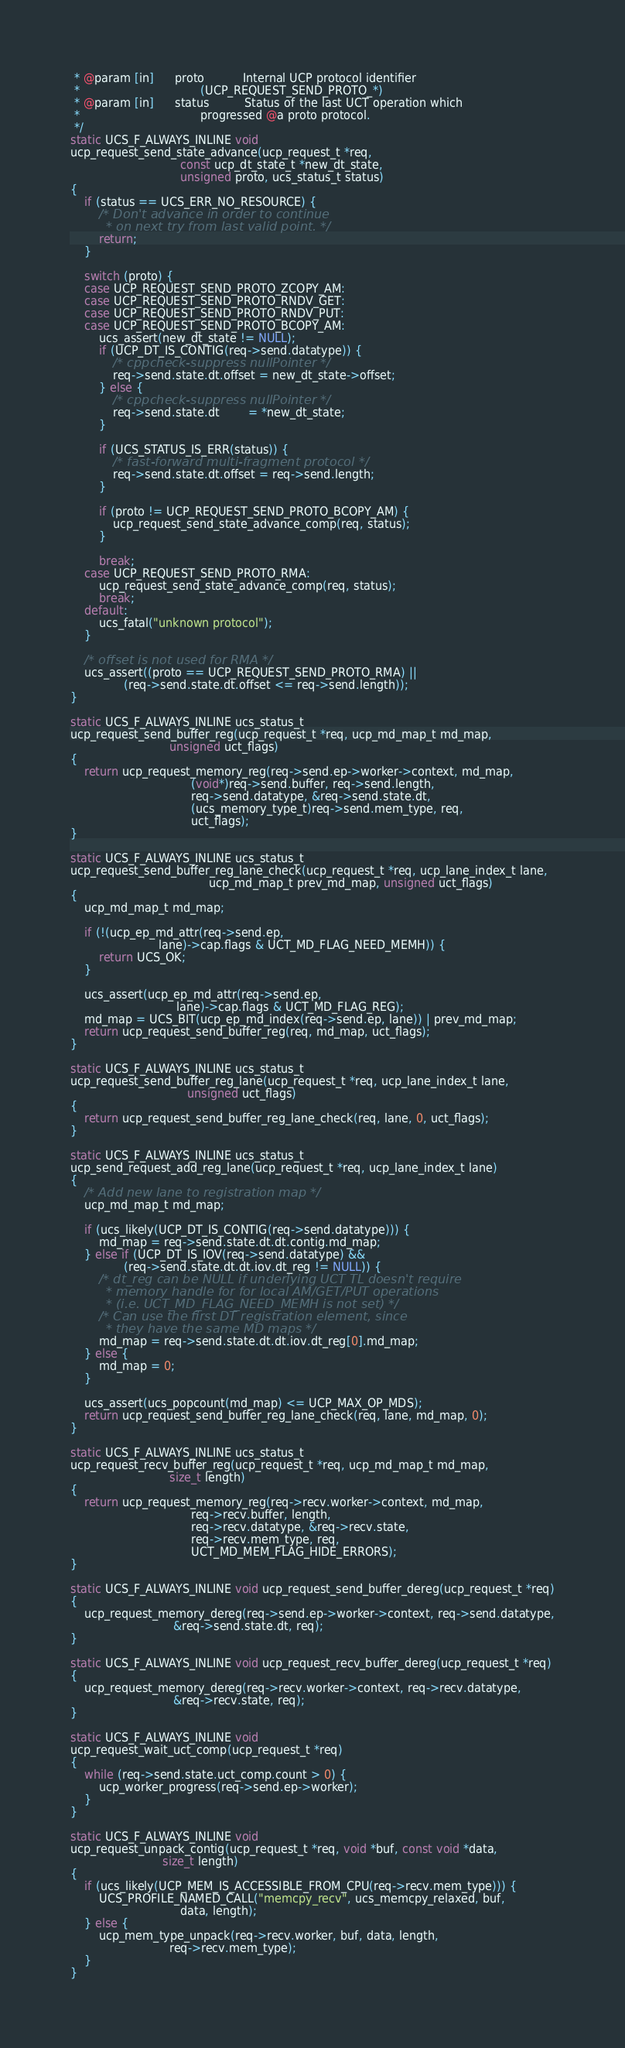<code> <loc_0><loc_0><loc_500><loc_500><_C++_> * @param [in]      proto           Internal UCP protocol identifier
 *                                  (UCP_REQUEST_SEND_PROTO_*)
 * @param [in]      status          Status of the last UCT operation which
 *                                  progressed @a proto protocol.
 */
static UCS_F_ALWAYS_INLINE void
ucp_request_send_state_advance(ucp_request_t *req,
                               const ucp_dt_state_t *new_dt_state,
                               unsigned proto, ucs_status_t status)
{
    if (status == UCS_ERR_NO_RESOURCE) {
        /* Don't advance in order to continue
         * on next try from last valid point. */
        return;
    }

    switch (proto) {
    case UCP_REQUEST_SEND_PROTO_ZCOPY_AM:
    case UCP_REQUEST_SEND_PROTO_RNDV_GET:
    case UCP_REQUEST_SEND_PROTO_RNDV_PUT:
    case UCP_REQUEST_SEND_PROTO_BCOPY_AM:
        ucs_assert(new_dt_state != NULL);
        if (UCP_DT_IS_CONTIG(req->send.datatype)) {
            /* cppcheck-suppress nullPointer */
            req->send.state.dt.offset = new_dt_state->offset;
        } else {
            /* cppcheck-suppress nullPointer */
            req->send.state.dt        = *new_dt_state;
        }

        if (UCS_STATUS_IS_ERR(status)) {
            /* fast-forward multi-fragment protocol */
            req->send.state.dt.offset = req->send.length;
        }

        if (proto != UCP_REQUEST_SEND_PROTO_BCOPY_AM) {
            ucp_request_send_state_advance_comp(req, status);
        }

        break;
    case UCP_REQUEST_SEND_PROTO_RMA:
        ucp_request_send_state_advance_comp(req, status);
        break;
    default:
        ucs_fatal("unknown protocol");
    }

    /* offset is not used for RMA */
    ucs_assert((proto == UCP_REQUEST_SEND_PROTO_RMA) ||
               (req->send.state.dt.offset <= req->send.length));
}

static UCS_F_ALWAYS_INLINE ucs_status_t
ucp_request_send_buffer_reg(ucp_request_t *req, ucp_md_map_t md_map,
                            unsigned uct_flags)
{
    return ucp_request_memory_reg(req->send.ep->worker->context, md_map,
                                  (void*)req->send.buffer, req->send.length,
                                  req->send.datatype, &req->send.state.dt,
                                  (ucs_memory_type_t)req->send.mem_type, req,
                                  uct_flags);
}

static UCS_F_ALWAYS_INLINE ucs_status_t
ucp_request_send_buffer_reg_lane_check(ucp_request_t *req, ucp_lane_index_t lane,
                                       ucp_md_map_t prev_md_map, unsigned uct_flags)
{
    ucp_md_map_t md_map;

    if (!(ucp_ep_md_attr(req->send.ep,
                         lane)->cap.flags & UCT_MD_FLAG_NEED_MEMH)) {
        return UCS_OK;
    }

    ucs_assert(ucp_ep_md_attr(req->send.ep,
                              lane)->cap.flags & UCT_MD_FLAG_REG);
    md_map = UCS_BIT(ucp_ep_md_index(req->send.ep, lane)) | prev_md_map;
    return ucp_request_send_buffer_reg(req, md_map, uct_flags);
}

static UCS_F_ALWAYS_INLINE ucs_status_t
ucp_request_send_buffer_reg_lane(ucp_request_t *req, ucp_lane_index_t lane,
                                 unsigned uct_flags)
{
    return ucp_request_send_buffer_reg_lane_check(req, lane, 0, uct_flags);
}

static UCS_F_ALWAYS_INLINE ucs_status_t
ucp_send_request_add_reg_lane(ucp_request_t *req, ucp_lane_index_t lane)
{
    /* Add new lane to registration map */
    ucp_md_map_t md_map;

    if (ucs_likely(UCP_DT_IS_CONTIG(req->send.datatype))) {
        md_map = req->send.state.dt.dt.contig.md_map;
    } else if (UCP_DT_IS_IOV(req->send.datatype) &&
               (req->send.state.dt.dt.iov.dt_reg != NULL)) {
        /* dt_reg can be NULL if underlying UCT TL doesn't require
         * memory handle for for local AM/GET/PUT operations
         * (i.e. UCT_MD_FLAG_NEED_MEMH is not set) */
        /* Can use the first DT registration element, since
         * they have the same MD maps */
        md_map = req->send.state.dt.dt.iov.dt_reg[0].md_map;
    } else {
        md_map = 0;
    }

    ucs_assert(ucs_popcount(md_map) <= UCP_MAX_OP_MDS);
    return ucp_request_send_buffer_reg_lane_check(req, lane, md_map, 0);
}

static UCS_F_ALWAYS_INLINE ucs_status_t
ucp_request_recv_buffer_reg(ucp_request_t *req, ucp_md_map_t md_map,
                            size_t length)
{
    return ucp_request_memory_reg(req->recv.worker->context, md_map,
                                  req->recv.buffer, length,
                                  req->recv.datatype, &req->recv.state,
                                  req->recv.mem_type, req,
                                  UCT_MD_MEM_FLAG_HIDE_ERRORS);
}

static UCS_F_ALWAYS_INLINE void ucp_request_send_buffer_dereg(ucp_request_t *req)
{
    ucp_request_memory_dereg(req->send.ep->worker->context, req->send.datatype,
                             &req->send.state.dt, req);
}

static UCS_F_ALWAYS_INLINE void ucp_request_recv_buffer_dereg(ucp_request_t *req)
{
    ucp_request_memory_dereg(req->recv.worker->context, req->recv.datatype,
                             &req->recv.state, req);
}

static UCS_F_ALWAYS_INLINE void
ucp_request_wait_uct_comp(ucp_request_t *req)
{
    while (req->send.state.uct_comp.count > 0) {
        ucp_worker_progress(req->send.ep->worker);
    }
}

static UCS_F_ALWAYS_INLINE void
ucp_request_unpack_contig(ucp_request_t *req, void *buf, const void *data,
                          size_t length)
{
    if (ucs_likely(UCP_MEM_IS_ACCESSIBLE_FROM_CPU(req->recv.mem_type))) {
        UCS_PROFILE_NAMED_CALL("memcpy_recv", ucs_memcpy_relaxed, buf,
                               data, length);
    } else {
        ucp_mem_type_unpack(req->recv.worker, buf, data, length,
                            req->recv.mem_type);
    }
}
</code> 